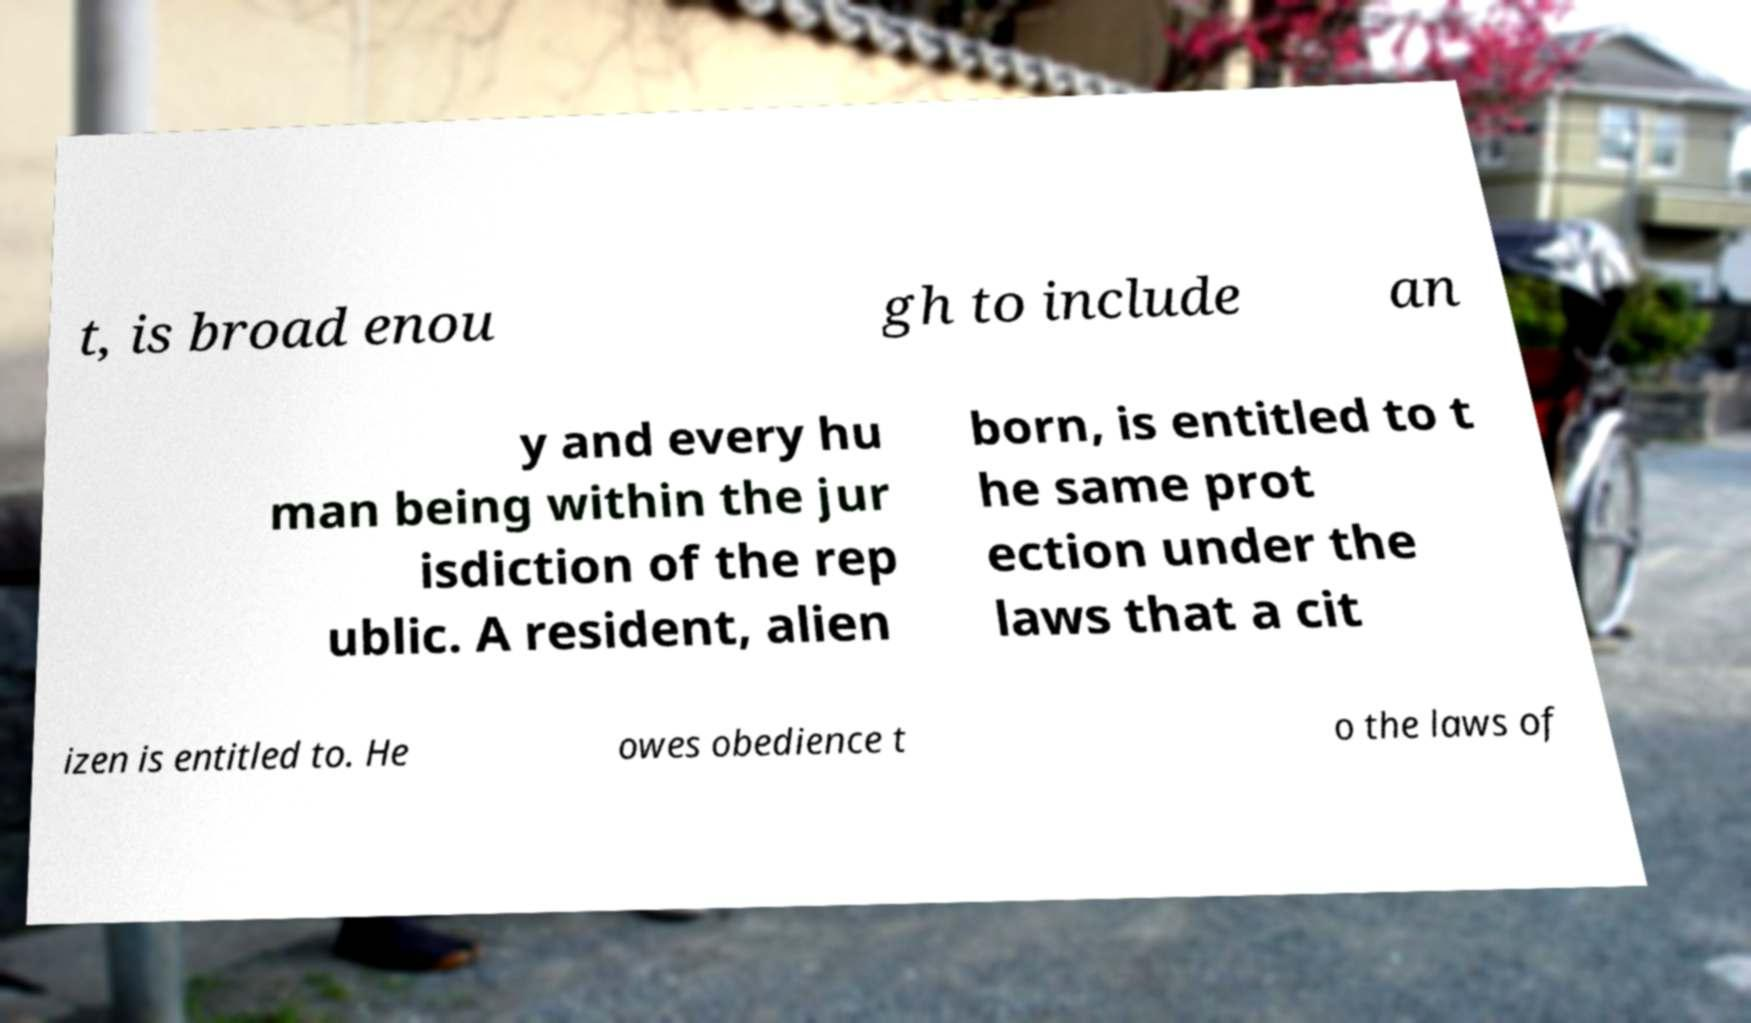What messages or text are displayed in this image? I need them in a readable, typed format. t, is broad enou gh to include an y and every hu man being within the jur isdiction of the rep ublic. A resident, alien born, is entitled to t he same prot ection under the laws that a cit izen is entitled to. He owes obedience t o the laws of 